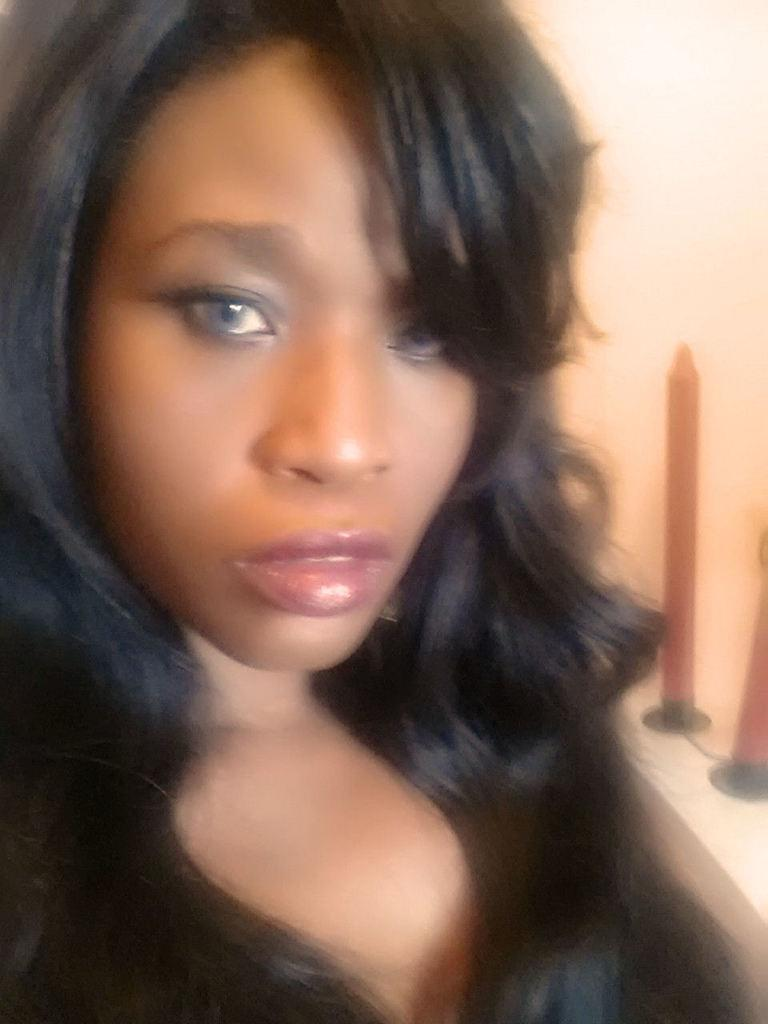Who is present in the image? There is a woman in the image. What objects can be seen on the table in the image? There are candles on a table in the image. What is visible in the background of the image? There is a wall visible in the image. Can you describe the setting of the image? The image may have been taken in a room, as there is a table and a wall visible. What type of milk is being poured into the woman's throat in the image? There is no milk or any action involving the woman's throat depicted in the image. 